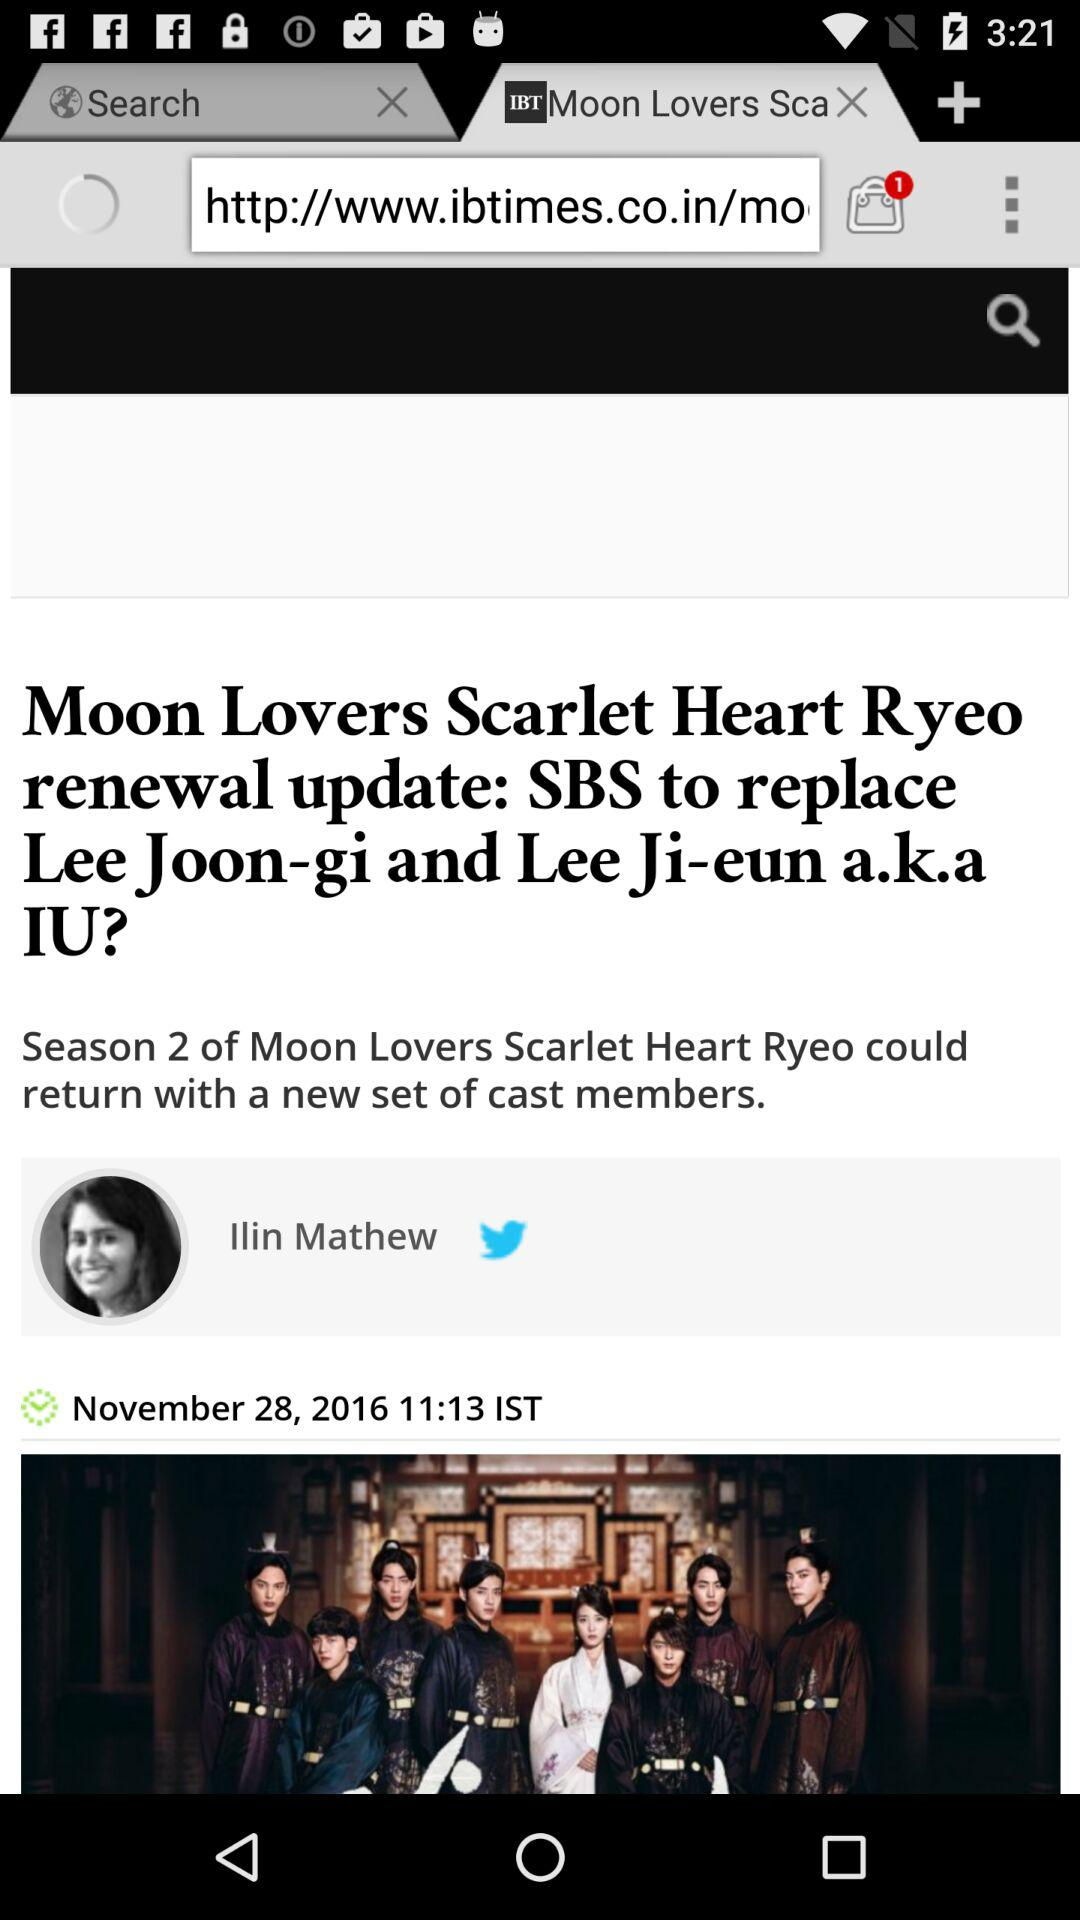When will season 2 of "Moon Lovers Scarlet Heart Ryeo" be released?
When the provided information is insufficient, respond with <no answer>. <no answer> 